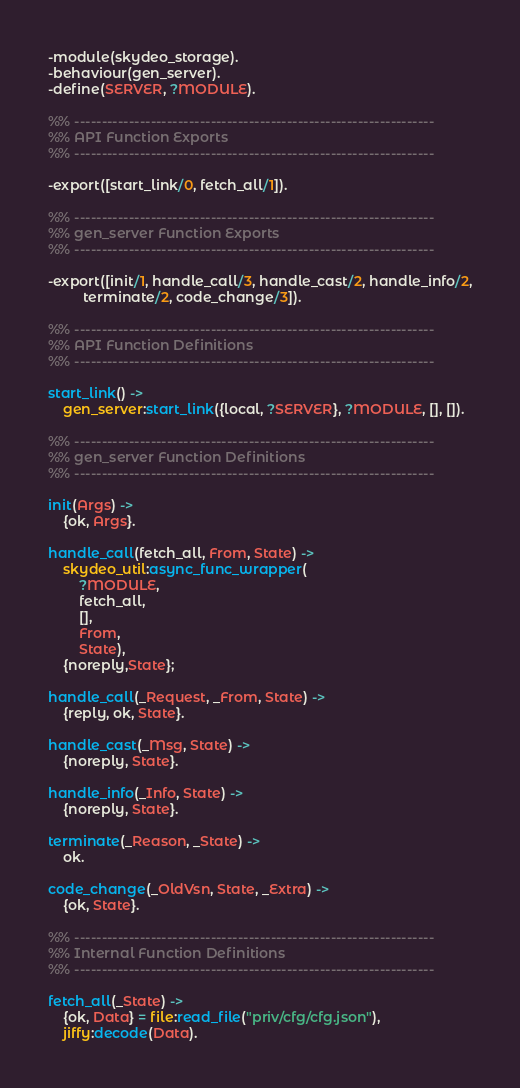Convert code to text. <code><loc_0><loc_0><loc_500><loc_500><_Erlang_>-module(skydeo_storage).
-behaviour(gen_server).
-define(SERVER, ?MODULE).

%% ------------------------------------------------------------------
%% API Function Exports
%% ------------------------------------------------------------------

-export([start_link/0, fetch_all/1]).

%% ------------------------------------------------------------------
%% gen_server Function Exports
%% ------------------------------------------------------------------

-export([init/1, handle_call/3, handle_cast/2, handle_info/2,
         terminate/2, code_change/3]).

%% ------------------------------------------------------------------
%% API Function Definitions
%% ------------------------------------------------------------------

start_link() ->
    gen_server:start_link({local, ?SERVER}, ?MODULE, [], []).

%% ------------------------------------------------------------------
%% gen_server Function Definitions
%% ------------------------------------------------------------------

init(Args) ->
    {ok, Args}.

handle_call(fetch_all, From, State) ->
	skydeo_util:async_func_wrapper(
        ?MODULE, 
        fetch_all, 
        [], 
        From, 
        State),
    {noreply,State};

handle_call(_Request, _From, State) ->
    {reply, ok, State}.

handle_cast(_Msg, State) ->
    {noreply, State}.

handle_info(_Info, State) ->
    {noreply, State}.

terminate(_Reason, _State) ->
    ok.

code_change(_OldVsn, State, _Extra) ->
    {ok, State}.

%% ------------------------------------------------------------------
%% Internal Function Definitions
%% ------------------------------------------------------------------

fetch_all(_State) ->
	{ok, Data} = file:read_file("priv/cfg/cfg.json"), 
	jiffy:decode(Data).

</code> 